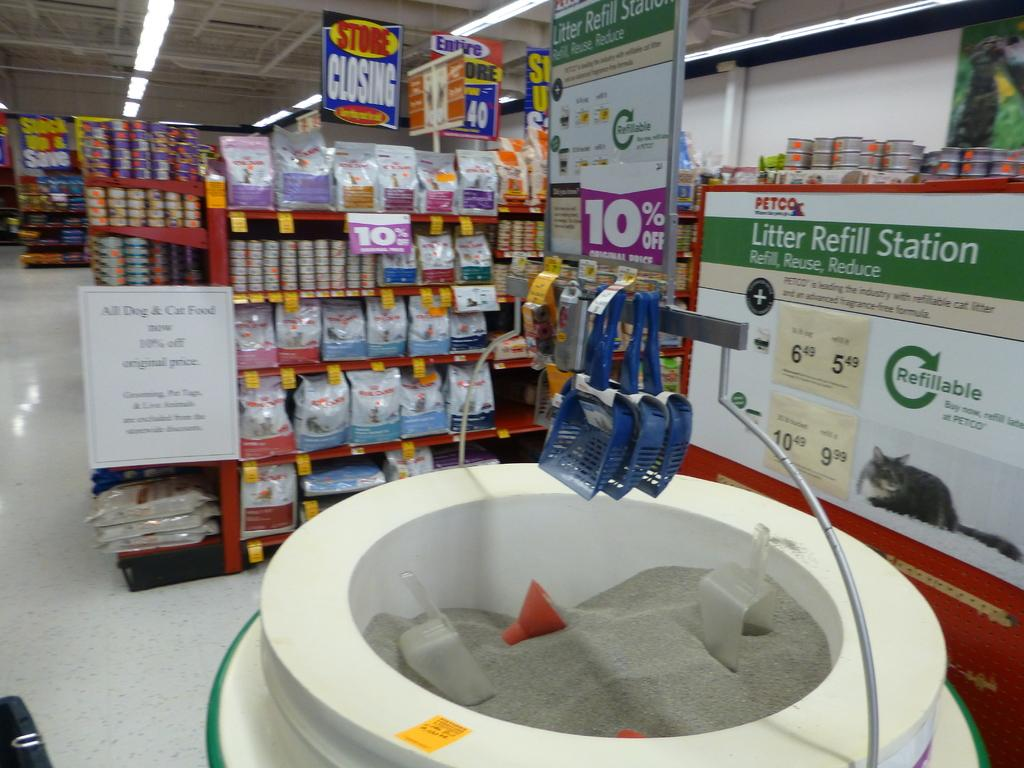<image>
Write a terse but informative summary of the picture. A litter refill station is set in the main aisle of a Petco with litter scoop hanging above it. 